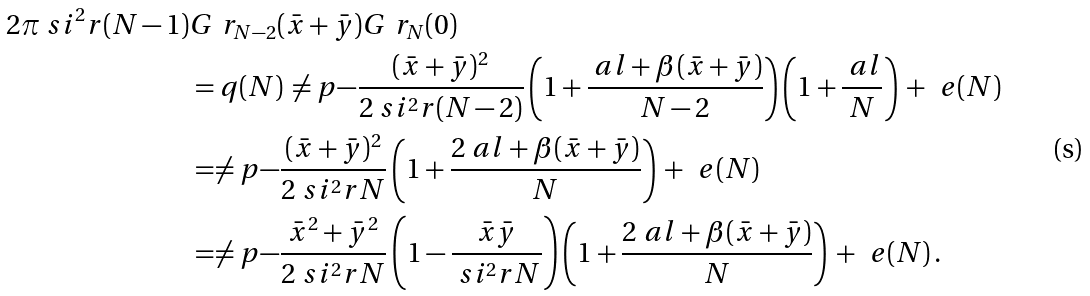<formula> <loc_0><loc_0><loc_500><loc_500>2 \pi \ s i ^ { 2 } _ { \ } r ( N - 1 ) & G ^ { \ } r _ { N - 2 } ( \bar { x } + \bar { y } ) G ^ { \ } r _ { N } ( 0 ) \\ & = q ( N ) \, \ne p { - \frac { ( \bar { x } + \bar { y } ) ^ { 2 } } { 2 \ s i ^ { 2 } _ { \ } r ( N - 2 ) } } \left ( 1 + \frac { \ a l + \beta ( \bar { x } + \bar { y } ) } { N - 2 } \right ) \left ( 1 + \frac { \ a l } { N } \right ) \, + \, \ e ( N ) \\ & = \ne p { - \frac { ( \bar { x } + \bar { y } ) ^ { 2 } } { 2 \ s i ^ { 2 } _ { \ } r N } } \left ( 1 + \frac { 2 \ a l + \beta ( \bar { x } + \bar { y } ) } { N } \right ) \, + \, \ e ( N ) \\ & = \ne p { - \frac { \bar { x } ^ { 2 } + \bar { y } ^ { 2 } } { 2 \ s i ^ { 2 } _ { \ } r N } } \left ( 1 - \frac { \bar { x } \bar { y } } { \ s i ^ { 2 } _ { \ } r N } \right ) \left ( 1 + \frac { 2 \ a l + \beta ( \bar { x } + \bar { y } ) } { N } \right ) \, + \, \ e ( N ) \, .</formula> 